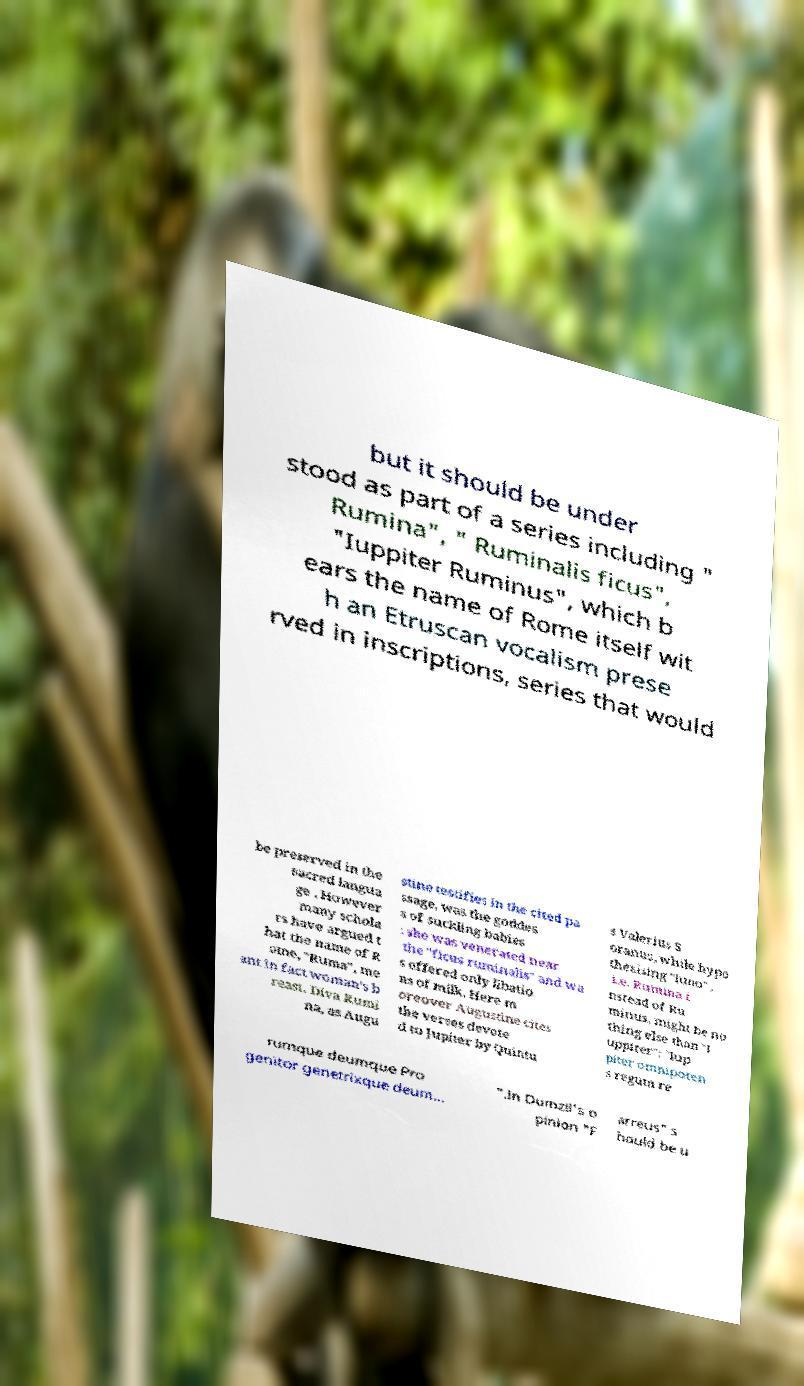What messages or text are displayed in this image? I need them in a readable, typed format. but it should be under stood as part of a series including " Rumina", " Ruminalis ficus", "Iuppiter Ruminus", which b ears the name of Rome itself wit h an Etruscan vocalism prese rved in inscriptions, series that would be preserved in the sacred langua ge . However many schola rs have argued t hat the name of R ome, "Ruma", me ant in fact woman's b reast. Diva Rumi na, as Augu stine testifies in the cited pa ssage, was the goddes s of suckling babies : she was venerated near the "ficus ruminalis" and wa s offered only libatio ns of milk. Here m oreover Augustine cites the verses devote d to Jupiter by Quintu s Valerius S oranus, while hypo thesising "Iuno" , i.e. Rumina i nstead of Ru minus, might be no thing else than "I uppiter": "Iup piter omnipoten s regum re rumque deumque Pro genitor genetrixque deum... ".In Dumzil's o pinion "F arreus" s hould be u 